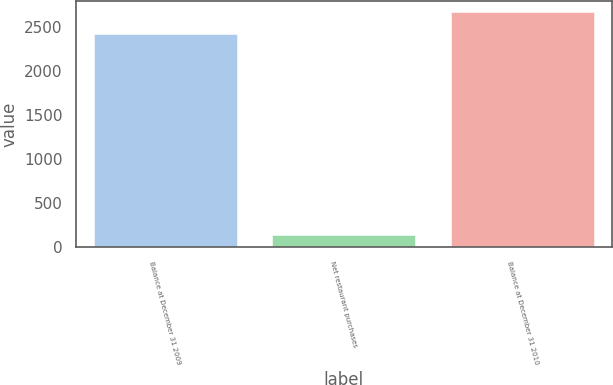Convert chart to OTSL. <chart><loc_0><loc_0><loc_500><loc_500><bar_chart><fcel>Balance at December 31 2009<fcel>Net restaurant purchases<fcel>Balance at December 31 2010<nl><fcel>2425.2<fcel>134.1<fcel>2670.4<nl></chart> 